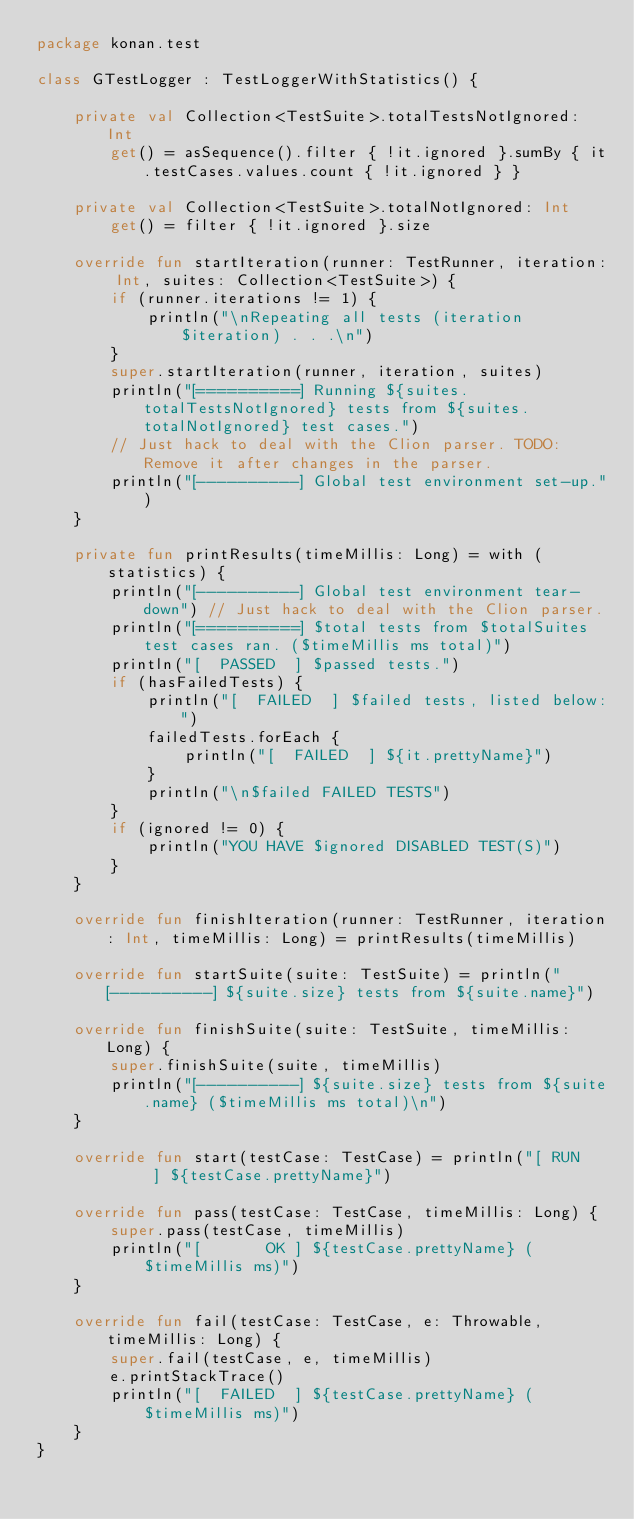<code> <loc_0><loc_0><loc_500><loc_500><_Kotlin_>package konan.test

class GTestLogger : TestLoggerWithStatistics() {

    private val Collection<TestSuite>.totalTestsNotIgnored: Int
        get() = asSequence().filter { !it.ignored }.sumBy { it.testCases.values.count { !it.ignored } }

    private val Collection<TestSuite>.totalNotIgnored: Int
        get() = filter { !it.ignored }.size

    override fun startIteration(runner: TestRunner, iteration: Int, suites: Collection<TestSuite>) {
        if (runner.iterations != 1) {
            println("\nRepeating all tests (iteration $iteration) . . .\n")
        }
        super.startIteration(runner, iteration, suites)
        println("[==========] Running ${suites.totalTestsNotIgnored} tests from ${suites.totalNotIgnored} test cases.")
        // Just hack to deal with the Clion parser. TODO: Remove it after changes in the parser.
        println("[----------] Global test environment set-up.")
    }

    private fun printResults(timeMillis: Long) = with (statistics) {
        println("[----------] Global test environment tear-down") // Just hack to deal with the Clion parser.
        println("[==========] $total tests from $totalSuites test cases ran. ($timeMillis ms total)")
        println("[  PASSED  ] $passed tests.")
        if (hasFailedTests) {
            println("[  FAILED  ] $failed tests, listed below:")
            failedTests.forEach {
                println("[  FAILED  ] ${it.prettyName}")
            }
            println("\n$failed FAILED TESTS")
        }
        if (ignored != 0) {
            println("YOU HAVE $ignored DISABLED TEST(S)")
        }
    }

    override fun finishIteration(runner: TestRunner, iteration: Int, timeMillis: Long) = printResults(timeMillis)

    override fun startSuite(suite: TestSuite) = println("[----------] ${suite.size} tests from ${suite.name}")

    override fun finishSuite(suite: TestSuite, timeMillis: Long) {
        super.finishSuite(suite, timeMillis)
        println("[----------] ${suite.size} tests from ${suite.name} ($timeMillis ms total)\n")
    }

    override fun start(testCase: TestCase) = println("[ RUN      ] ${testCase.prettyName}")

    override fun pass(testCase: TestCase, timeMillis: Long) {
        super.pass(testCase, timeMillis)
        println("[       OK ] ${testCase.prettyName} ($timeMillis ms)")
    }

    override fun fail(testCase: TestCase, e: Throwable, timeMillis: Long) {
        super.fail(testCase, e, timeMillis)
        e.printStackTrace()
        println("[  FAILED  ] ${testCase.prettyName} ($timeMillis ms)")
    }
}
</code> 